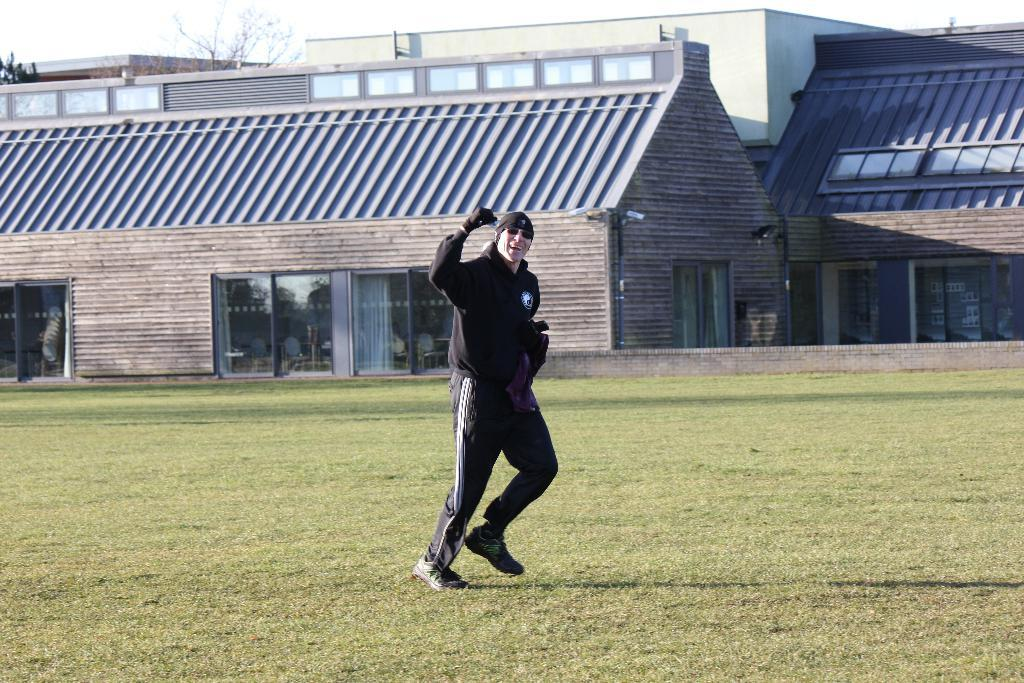What is the main subject of the image? There is a person in the image. What is the person's position in the image? The person is on the ground. What type of surface is the person on? There is grass on the ground. What is the person wearing? The person is wearing a black dress. What can be seen in the background of the image? There is a house and the sky visible in the background of the image. How many hooks are visible in the image? There are no hooks present in the image. What fact can be learned about the person's family from the image? The image does not provide any information about the person's family, so we cannot determine any facts about them from the image. 